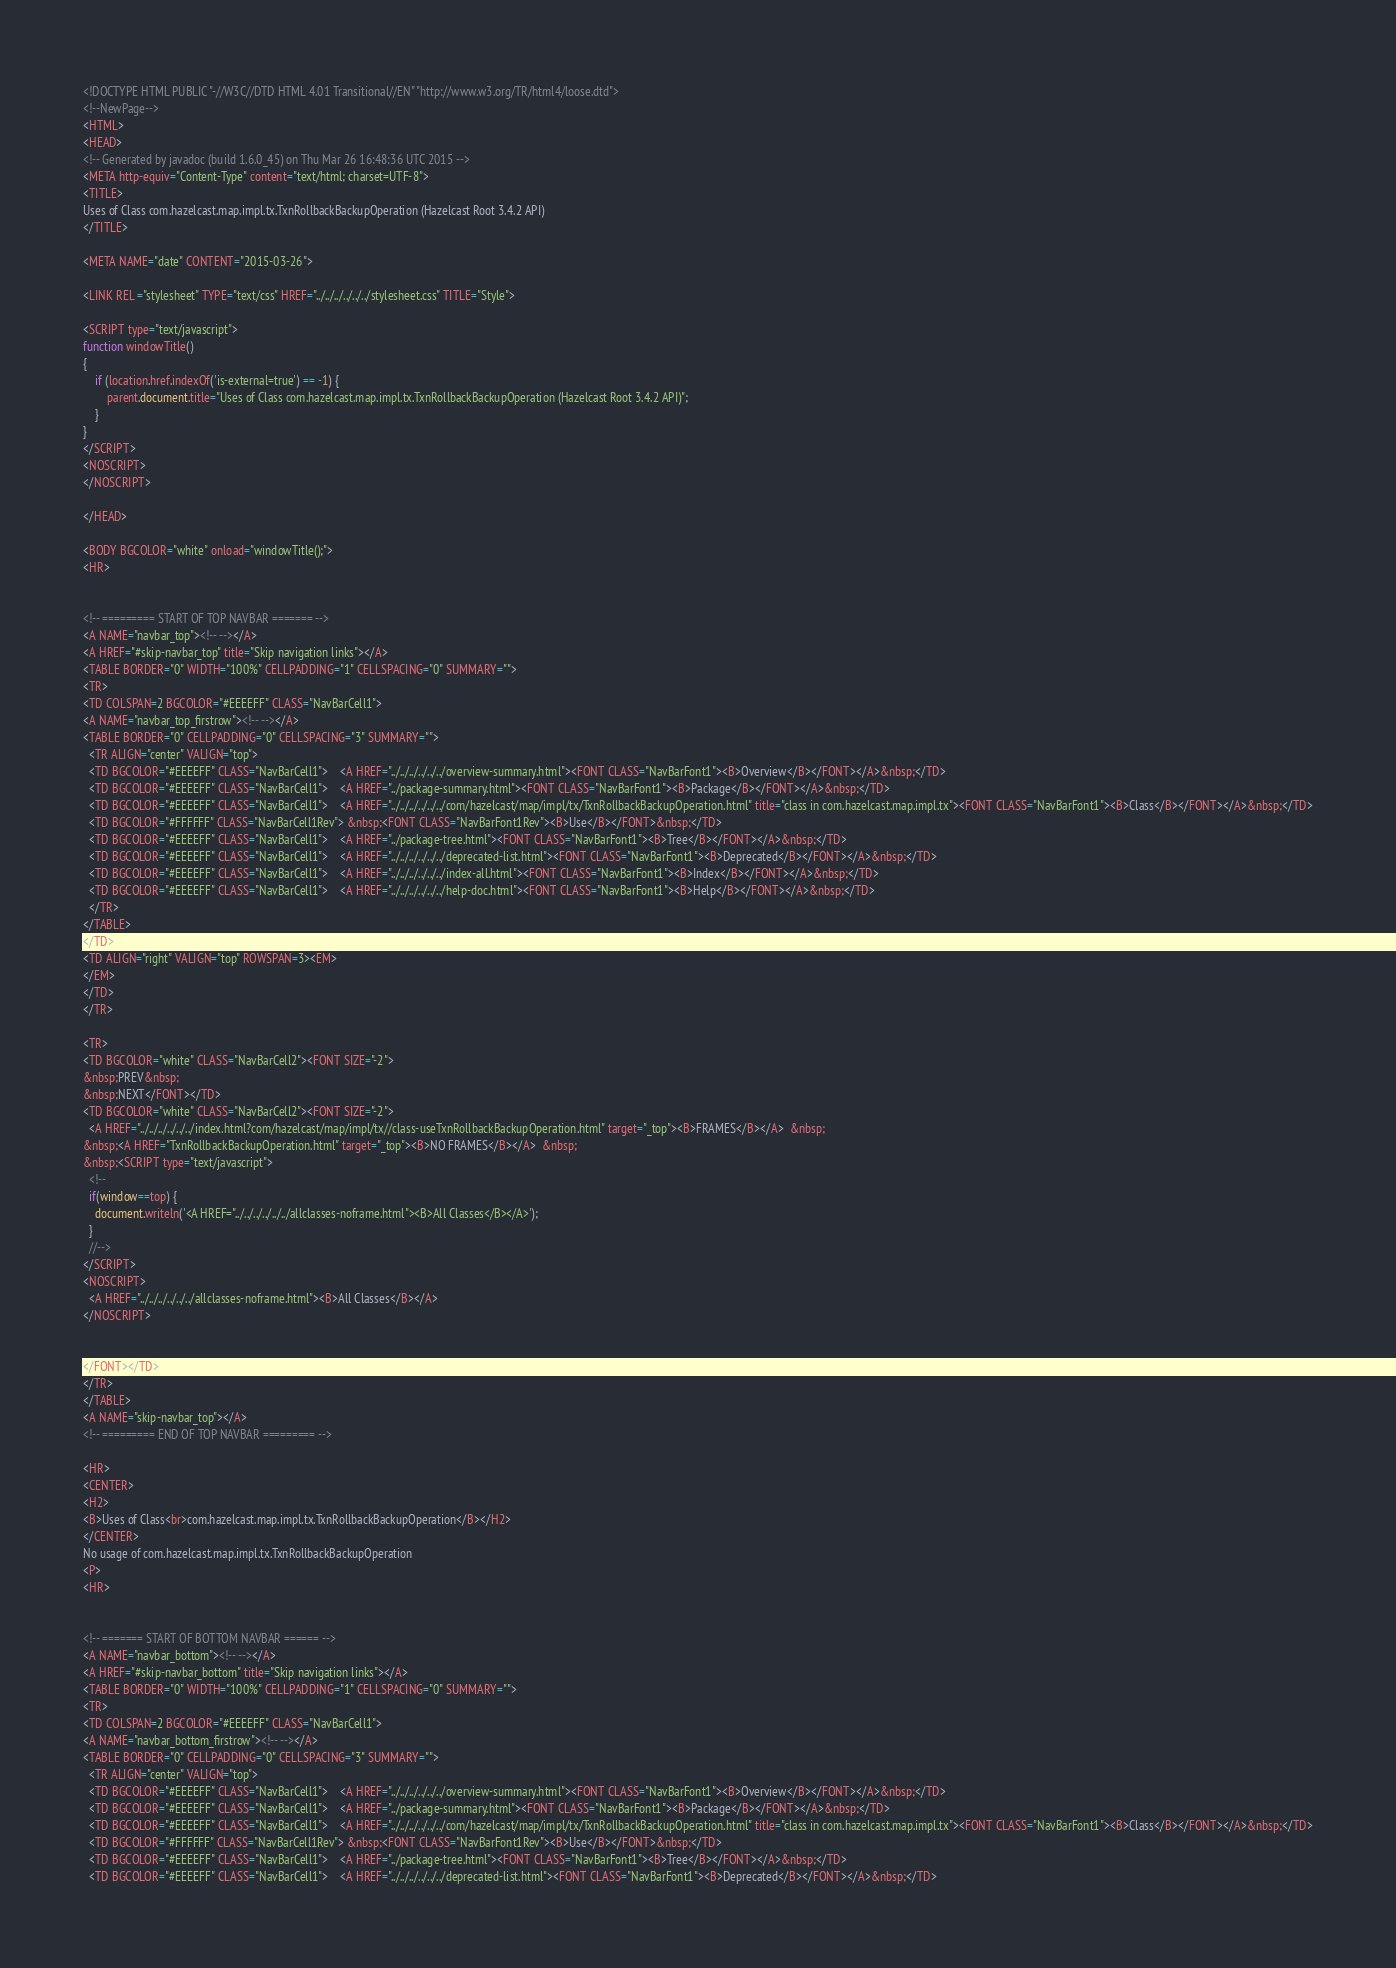<code> <loc_0><loc_0><loc_500><loc_500><_HTML_><!DOCTYPE HTML PUBLIC "-//W3C//DTD HTML 4.01 Transitional//EN" "http://www.w3.org/TR/html4/loose.dtd">
<!--NewPage-->
<HTML>
<HEAD>
<!-- Generated by javadoc (build 1.6.0_45) on Thu Mar 26 16:48:36 UTC 2015 -->
<META http-equiv="Content-Type" content="text/html; charset=UTF-8">
<TITLE>
Uses of Class com.hazelcast.map.impl.tx.TxnRollbackBackupOperation (Hazelcast Root 3.4.2 API)
</TITLE>

<META NAME="date" CONTENT="2015-03-26">

<LINK REL ="stylesheet" TYPE="text/css" HREF="../../../../../../stylesheet.css" TITLE="Style">

<SCRIPT type="text/javascript">
function windowTitle()
{
    if (location.href.indexOf('is-external=true') == -1) {
        parent.document.title="Uses of Class com.hazelcast.map.impl.tx.TxnRollbackBackupOperation (Hazelcast Root 3.4.2 API)";
    }
}
</SCRIPT>
<NOSCRIPT>
</NOSCRIPT>

</HEAD>

<BODY BGCOLOR="white" onload="windowTitle();">
<HR>


<!-- ========= START OF TOP NAVBAR ======= -->
<A NAME="navbar_top"><!-- --></A>
<A HREF="#skip-navbar_top" title="Skip navigation links"></A>
<TABLE BORDER="0" WIDTH="100%" CELLPADDING="1" CELLSPACING="0" SUMMARY="">
<TR>
<TD COLSPAN=2 BGCOLOR="#EEEEFF" CLASS="NavBarCell1">
<A NAME="navbar_top_firstrow"><!-- --></A>
<TABLE BORDER="0" CELLPADDING="0" CELLSPACING="3" SUMMARY="">
  <TR ALIGN="center" VALIGN="top">
  <TD BGCOLOR="#EEEEFF" CLASS="NavBarCell1">    <A HREF="../../../../../../overview-summary.html"><FONT CLASS="NavBarFont1"><B>Overview</B></FONT></A>&nbsp;</TD>
  <TD BGCOLOR="#EEEEFF" CLASS="NavBarCell1">    <A HREF="../package-summary.html"><FONT CLASS="NavBarFont1"><B>Package</B></FONT></A>&nbsp;</TD>
  <TD BGCOLOR="#EEEEFF" CLASS="NavBarCell1">    <A HREF="../../../../../../com/hazelcast/map/impl/tx/TxnRollbackBackupOperation.html" title="class in com.hazelcast.map.impl.tx"><FONT CLASS="NavBarFont1"><B>Class</B></FONT></A>&nbsp;</TD>
  <TD BGCOLOR="#FFFFFF" CLASS="NavBarCell1Rev"> &nbsp;<FONT CLASS="NavBarFont1Rev"><B>Use</B></FONT>&nbsp;</TD>
  <TD BGCOLOR="#EEEEFF" CLASS="NavBarCell1">    <A HREF="../package-tree.html"><FONT CLASS="NavBarFont1"><B>Tree</B></FONT></A>&nbsp;</TD>
  <TD BGCOLOR="#EEEEFF" CLASS="NavBarCell1">    <A HREF="../../../../../../deprecated-list.html"><FONT CLASS="NavBarFont1"><B>Deprecated</B></FONT></A>&nbsp;</TD>
  <TD BGCOLOR="#EEEEFF" CLASS="NavBarCell1">    <A HREF="../../../../../../index-all.html"><FONT CLASS="NavBarFont1"><B>Index</B></FONT></A>&nbsp;</TD>
  <TD BGCOLOR="#EEEEFF" CLASS="NavBarCell1">    <A HREF="../../../../../../help-doc.html"><FONT CLASS="NavBarFont1"><B>Help</B></FONT></A>&nbsp;</TD>
  </TR>
</TABLE>
</TD>
<TD ALIGN="right" VALIGN="top" ROWSPAN=3><EM>
</EM>
</TD>
</TR>

<TR>
<TD BGCOLOR="white" CLASS="NavBarCell2"><FONT SIZE="-2">
&nbsp;PREV&nbsp;
&nbsp;NEXT</FONT></TD>
<TD BGCOLOR="white" CLASS="NavBarCell2"><FONT SIZE="-2">
  <A HREF="../../../../../../index.html?com/hazelcast/map/impl/tx//class-useTxnRollbackBackupOperation.html" target="_top"><B>FRAMES</B></A>  &nbsp;
&nbsp;<A HREF="TxnRollbackBackupOperation.html" target="_top"><B>NO FRAMES</B></A>  &nbsp;
&nbsp;<SCRIPT type="text/javascript">
  <!--
  if(window==top) {
    document.writeln('<A HREF="../../../../../../allclasses-noframe.html"><B>All Classes</B></A>');
  }
  //-->
</SCRIPT>
<NOSCRIPT>
  <A HREF="../../../../../../allclasses-noframe.html"><B>All Classes</B></A>
</NOSCRIPT>


</FONT></TD>
</TR>
</TABLE>
<A NAME="skip-navbar_top"></A>
<!-- ========= END OF TOP NAVBAR ========= -->

<HR>
<CENTER>
<H2>
<B>Uses of Class<br>com.hazelcast.map.impl.tx.TxnRollbackBackupOperation</B></H2>
</CENTER>
No usage of com.hazelcast.map.impl.tx.TxnRollbackBackupOperation
<P>
<HR>


<!-- ======= START OF BOTTOM NAVBAR ====== -->
<A NAME="navbar_bottom"><!-- --></A>
<A HREF="#skip-navbar_bottom" title="Skip navigation links"></A>
<TABLE BORDER="0" WIDTH="100%" CELLPADDING="1" CELLSPACING="0" SUMMARY="">
<TR>
<TD COLSPAN=2 BGCOLOR="#EEEEFF" CLASS="NavBarCell1">
<A NAME="navbar_bottom_firstrow"><!-- --></A>
<TABLE BORDER="0" CELLPADDING="0" CELLSPACING="3" SUMMARY="">
  <TR ALIGN="center" VALIGN="top">
  <TD BGCOLOR="#EEEEFF" CLASS="NavBarCell1">    <A HREF="../../../../../../overview-summary.html"><FONT CLASS="NavBarFont1"><B>Overview</B></FONT></A>&nbsp;</TD>
  <TD BGCOLOR="#EEEEFF" CLASS="NavBarCell1">    <A HREF="../package-summary.html"><FONT CLASS="NavBarFont1"><B>Package</B></FONT></A>&nbsp;</TD>
  <TD BGCOLOR="#EEEEFF" CLASS="NavBarCell1">    <A HREF="../../../../../../com/hazelcast/map/impl/tx/TxnRollbackBackupOperation.html" title="class in com.hazelcast.map.impl.tx"><FONT CLASS="NavBarFont1"><B>Class</B></FONT></A>&nbsp;</TD>
  <TD BGCOLOR="#FFFFFF" CLASS="NavBarCell1Rev"> &nbsp;<FONT CLASS="NavBarFont1Rev"><B>Use</B></FONT>&nbsp;</TD>
  <TD BGCOLOR="#EEEEFF" CLASS="NavBarCell1">    <A HREF="../package-tree.html"><FONT CLASS="NavBarFont1"><B>Tree</B></FONT></A>&nbsp;</TD>
  <TD BGCOLOR="#EEEEFF" CLASS="NavBarCell1">    <A HREF="../../../../../../deprecated-list.html"><FONT CLASS="NavBarFont1"><B>Deprecated</B></FONT></A>&nbsp;</TD></code> 